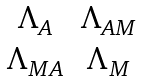<formula> <loc_0><loc_0><loc_500><loc_500>\begin{matrix} \Lambda _ { A } & \Lambda _ { A M } \\ \Lambda _ { M A } & \Lambda _ { M } \end{matrix}</formula> 